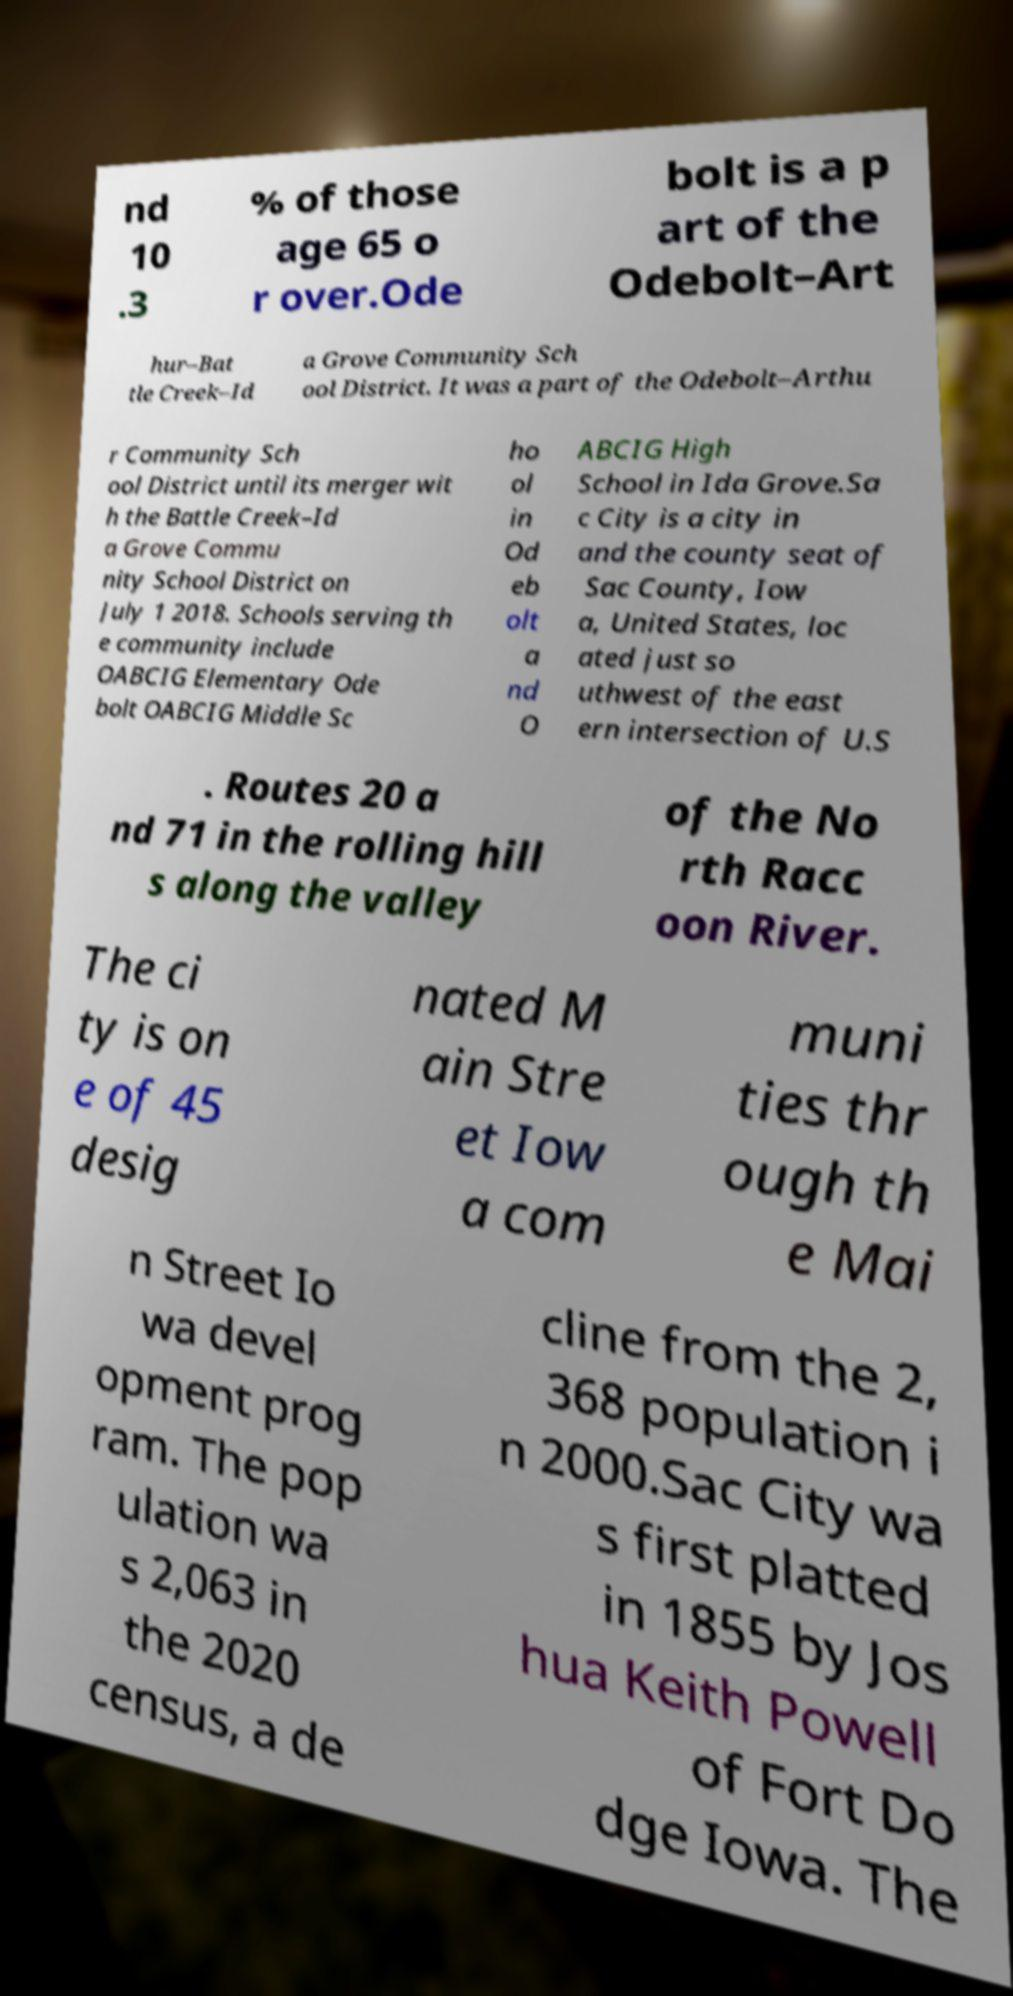Please read and relay the text visible in this image. What does it say? nd 10 .3 % of those age 65 o r over.Ode bolt is a p art of the Odebolt–Art hur–Bat tle Creek–Id a Grove Community Sch ool District. It was a part of the Odebolt–Arthu r Community Sch ool District until its merger wit h the Battle Creek–Id a Grove Commu nity School District on July 1 2018. Schools serving th e community include OABCIG Elementary Ode bolt OABCIG Middle Sc ho ol in Od eb olt a nd O ABCIG High School in Ida Grove.Sa c City is a city in and the county seat of Sac County, Iow a, United States, loc ated just so uthwest of the east ern intersection of U.S . Routes 20 a nd 71 in the rolling hill s along the valley of the No rth Racc oon River. The ci ty is on e of 45 desig nated M ain Stre et Iow a com muni ties thr ough th e Mai n Street Io wa devel opment prog ram. The pop ulation wa s 2,063 in the 2020 census, a de cline from the 2, 368 population i n 2000.Sac City wa s first platted in 1855 by Jos hua Keith Powell of Fort Do dge Iowa. The 